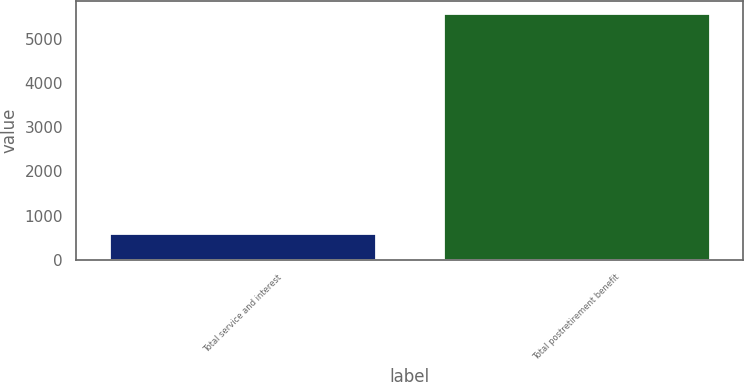Convert chart to OTSL. <chart><loc_0><loc_0><loc_500><loc_500><bar_chart><fcel>Total service and interest<fcel>Total postretirement benefit<nl><fcel>598<fcel>5591<nl></chart> 